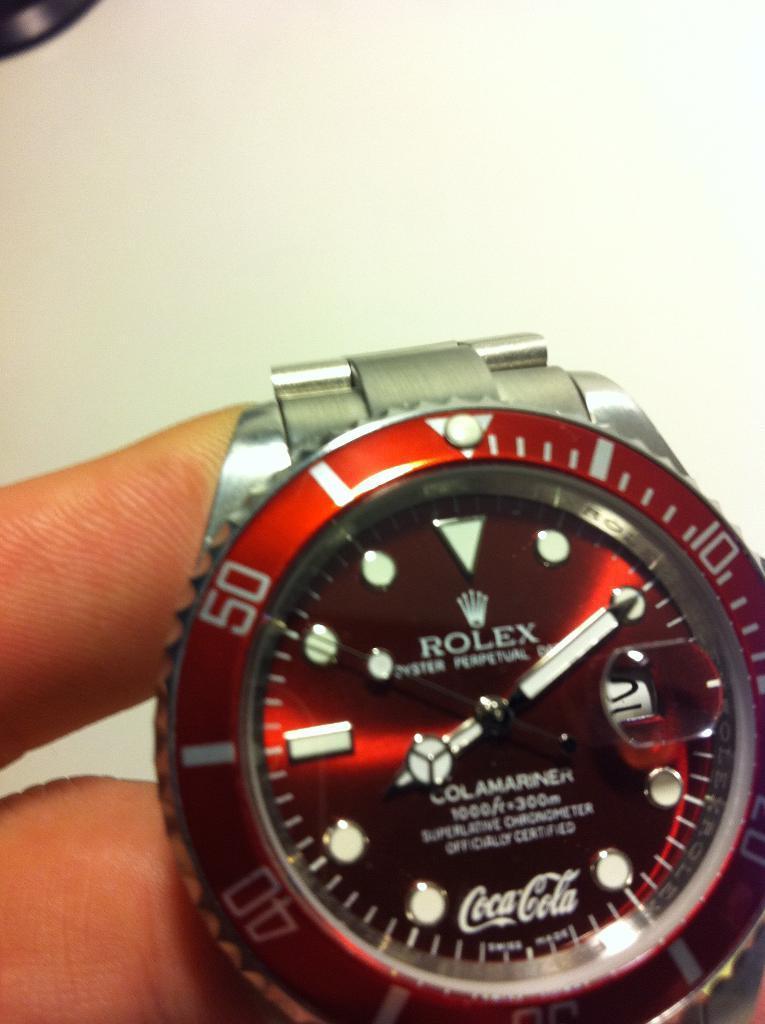Describe this image in one or two sentences. In this image we can see watch in person's hand. 